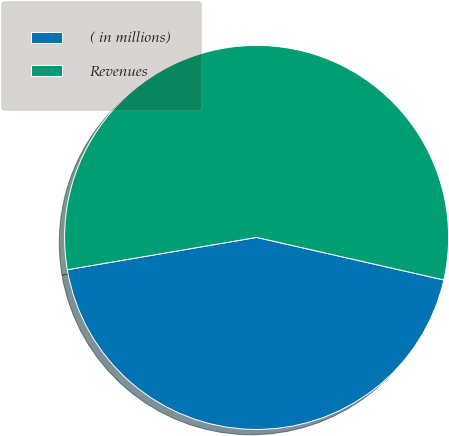Convert chart. <chart><loc_0><loc_0><loc_500><loc_500><pie_chart><fcel>( in millions)<fcel>Revenues<nl><fcel>43.75%<fcel>56.25%<nl></chart> 